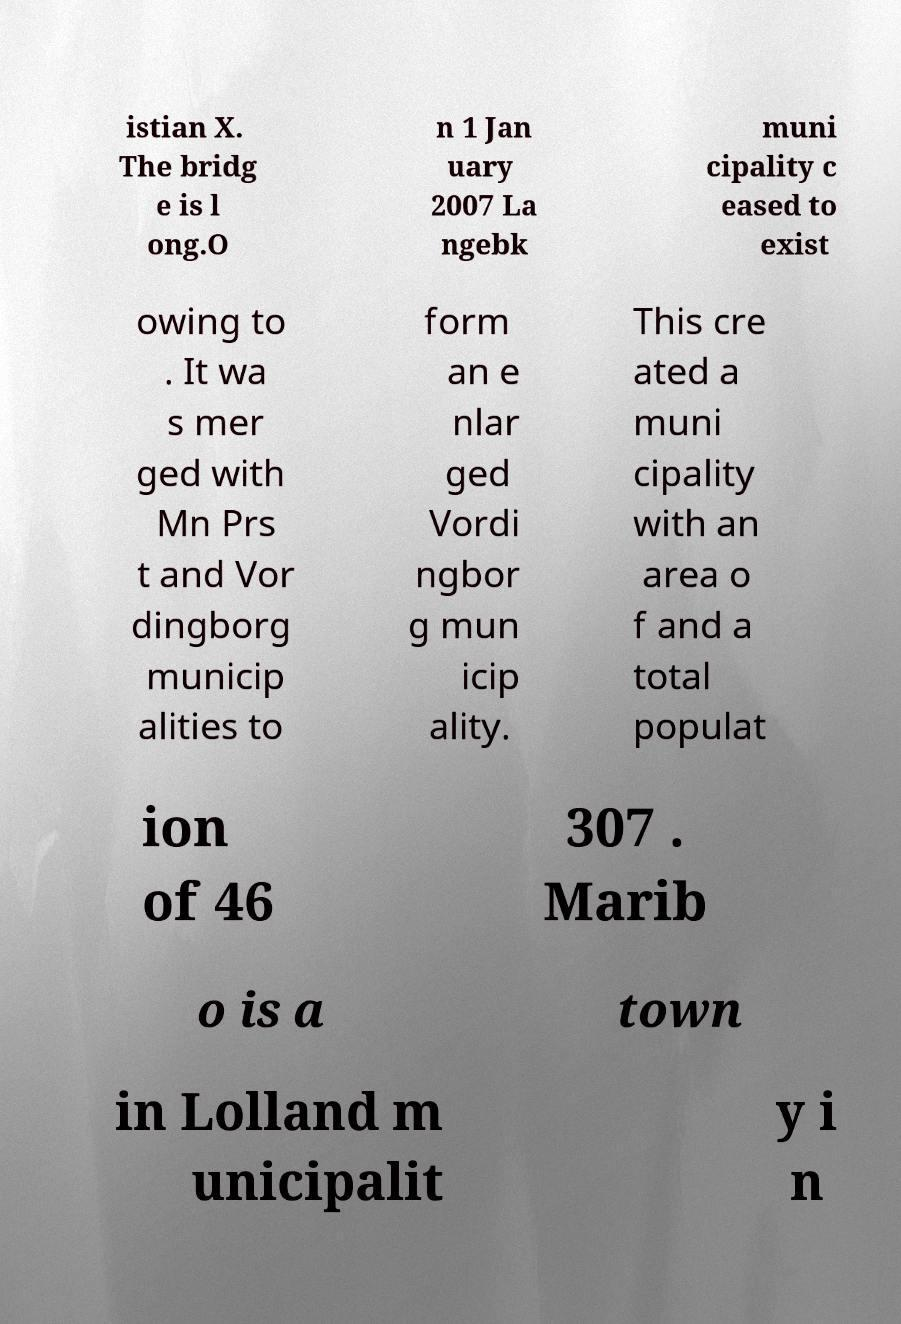Could you assist in decoding the text presented in this image and type it out clearly? istian X. The bridg e is l ong.O n 1 Jan uary 2007 La ngebk muni cipality c eased to exist owing to . It wa s mer ged with Mn Prs t and Vor dingborg municip alities to form an e nlar ged Vordi ngbor g mun icip ality. This cre ated a muni cipality with an area o f and a total populat ion of 46 307 . Marib o is a town in Lolland m unicipalit y i n 